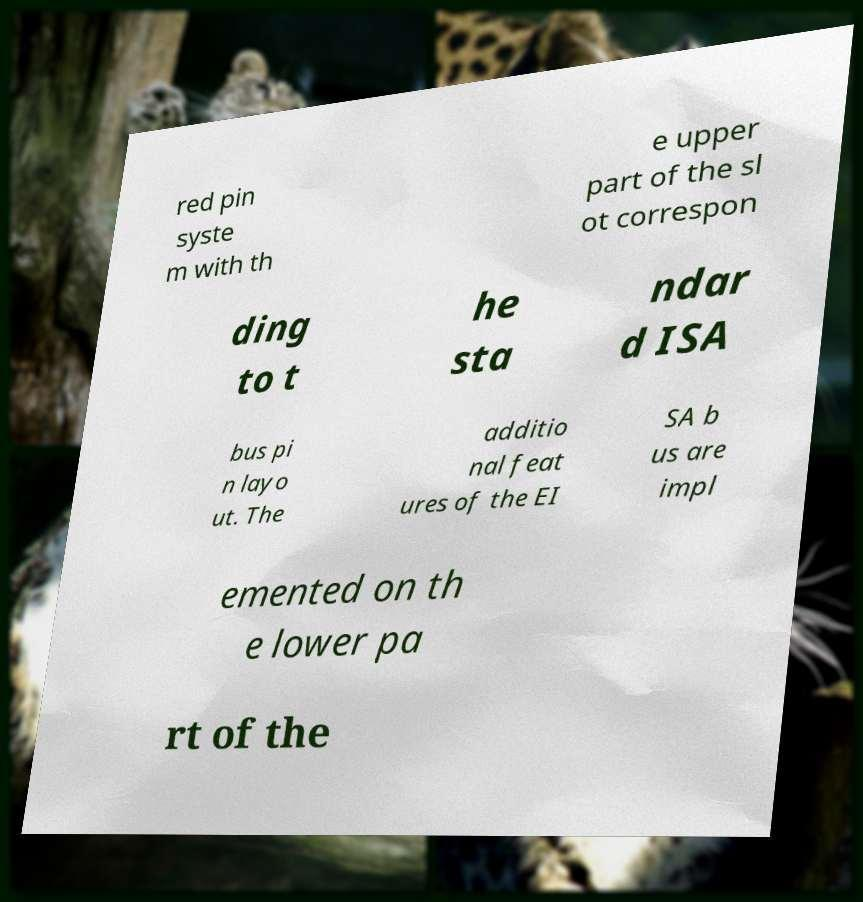There's text embedded in this image that I need extracted. Can you transcribe it verbatim? red pin syste m with th e upper part of the sl ot correspon ding to t he sta ndar d ISA bus pi n layo ut. The additio nal feat ures of the EI SA b us are impl emented on th e lower pa rt of the 